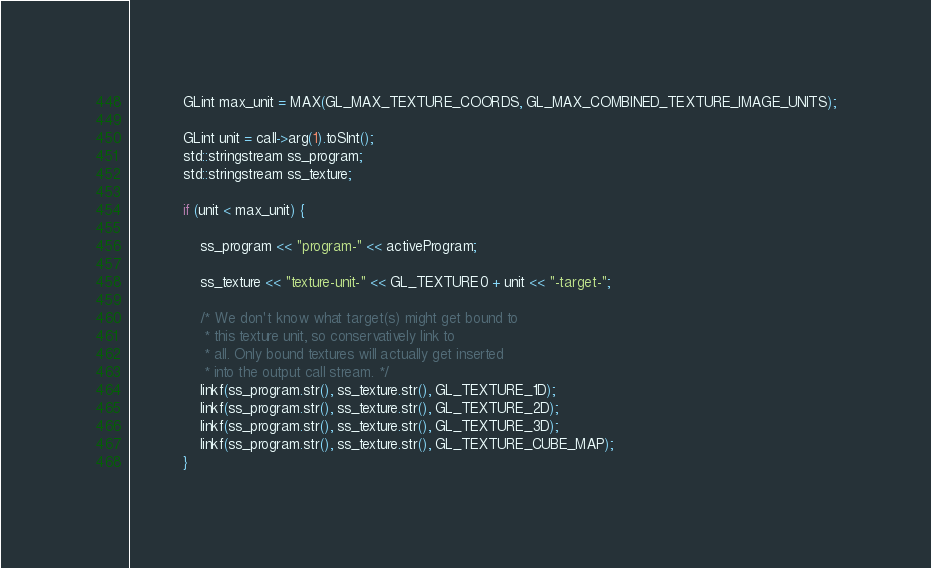<code> <loc_0><loc_0><loc_500><loc_500><_C++_>            GLint max_unit = MAX(GL_MAX_TEXTURE_COORDS, GL_MAX_COMBINED_TEXTURE_IMAGE_UNITS);

            GLint unit = call->arg(1).toSInt();
            std::stringstream ss_program;
            std::stringstream ss_texture;

            if (unit < max_unit) {

                ss_program << "program-" << activeProgram;

                ss_texture << "texture-unit-" << GL_TEXTURE0 + unit << "-target-";

                /* We don't know what target(s) might get bound to
                 * this texture unit, so conservatively link to
                 * all. Only bound textures will actually get inserted
                 * into the output call stream. */
                linkf(ss_program.str(), ss_texture.str(), GL_TEXTURE_1D);
                linkf(ss_program.str(), ss_texture.str(), GL_TEXTURE_2D);
                linkf(ss_program.str(), ss_texture.str(), GL_TEXTURE_3D);
                linkf(ss_program.str(), ss_texture.str(), GL_TEXTURE_CUBE_MAP);
            }</code> 